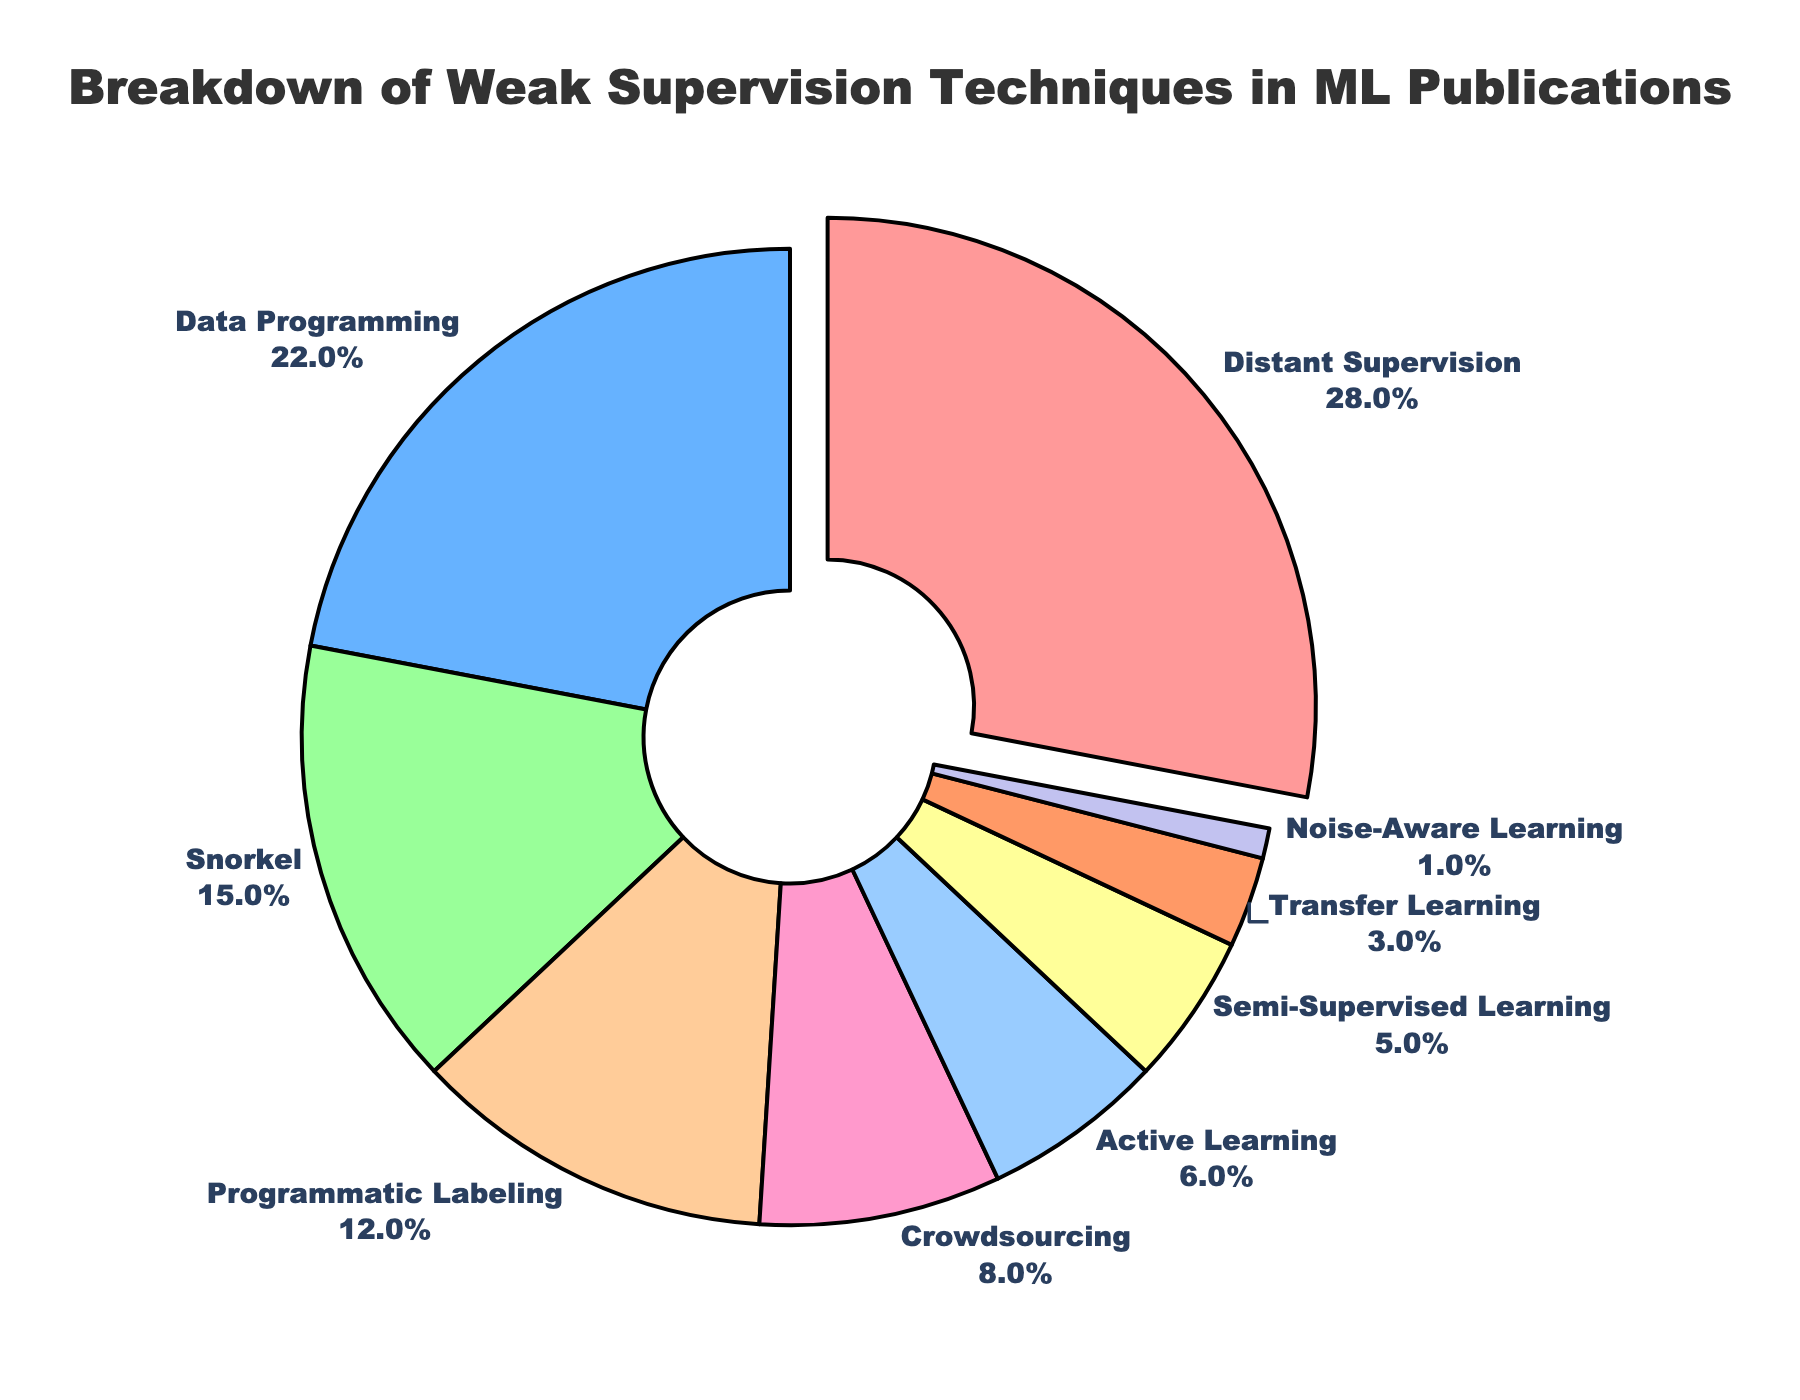What's the most common weak supervision technique according to the chart? The pie chart highlights the most common weak supervision technique by pulling out the slice that represents the highest percentage. In this case, the "Distant Supervision" slice is pulled out and represents 28% of the total.
Answer: Distant Supervision What's the combined percentage of "Snorkel" and "Programmatic Labeling"? By looking at the percentages on the pie chart, "Snorkel" is 15% and "Programmatic Labeling" is 12%. Adding these percentages together, we get 15% + 12% = 27%.
Answer: 27% Which technique's slice is smaller, "Crowdsourcing" or "Active Learning"? The pie chart shows percentages next to each slice. "Crowdsourcing" has a percentage of 8%, and "Active Learning" has a percentage of 6%. Comparing these, "Active Learning" has a smaller slice.
Answer: Active Learning How much larger is "Distant Supervision" compared to "Transfer Learning"? The percentage for "Distant Supervision" is 28% and for "Transfer Learning" is 3%. Subtracting these percentages, 28% - 3% = 25%.
Answer: 25% What percentage of the techniques represent 5% or less? Identifying from the pie chart, "Semi-Supervised Learning" is 5%, "Transfer Learning" is 3%, and "Noise-Aware Learning" is 1%. Summing these percentages, 5% + 3% + 1% = 9%.
Answer: 9% Which color slice is used to represent "Crowdsourcing"? The pie chart uses distinct colors for each segment. The slice representing "Crowdsourcing" would be visually identified; in this case, it is likely dark pink or a similar shade.
Answer: dark pink What's the difference in percentage between "Data Programming" and "Programmatic Labeling"? The pie chart shows "Data Programming" at 22% and "Programmatic Labeling" at 12%. Subtracting these values, 22% - 12% = 10%.
Answer: 10% If we group "Semi-Supervised Learning", "Transfer Learning", and "Noise-Aware Learning" together, what's their total percentage? Looking at the pie chart, "Semi-Supervised Learning" is 5%, "Transfer Learning" is 3%, and "Noise-Aware Learning" is 1%. Summing them, 5% + 3% + 1% = 9%.
Answer: 9% Are there more techniques with a percentage greater than 10% or less than 10%? From the pie chart, the techniques greater than 10% are "Distant Supervision" (28%), "Data Programming" (22%), "Snorkel" (15%), and "Programmatic Labeling" (12%), which are 4 techniques. The techniques less than 10% are "Crowdsourcing" (8%), "Active Learning" (6%), "Semi-Supervised Learning" (5%), "Transfer Learning" (3%), and "Noise-Aware Learning" (1%), which are 5 techniques.
Answer: less than 10% Which technique has the smallest representation in the chart? The pie chart displays all percentages, and the smallest slice has a representation of 1%, which belongs to "Noise-Aware Learning".
Answer: Noise-Aware Learning 